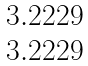<formula> <loc_0><loc_0><loc_500><loc_500>\begin{matrix} 3 . 2 2 2 9 \\ 3 . 2 2 2 9 \end{matrix}</formula> 